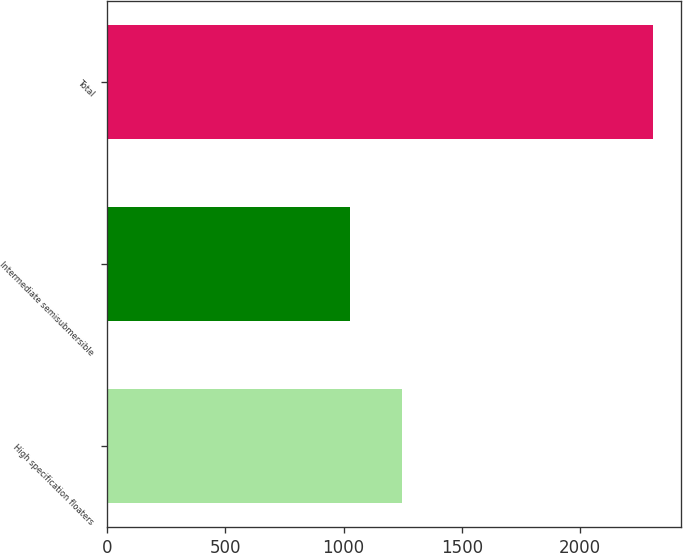<chart> <loc_0><loc_0><loc_500><loc_500><bar_chart><fcel>High specification floaters<fcel>Intermediate semisubmersible<fcel>Total<nl><fcel>1245<fcel>1026<fcel>2310<nl></chart> 